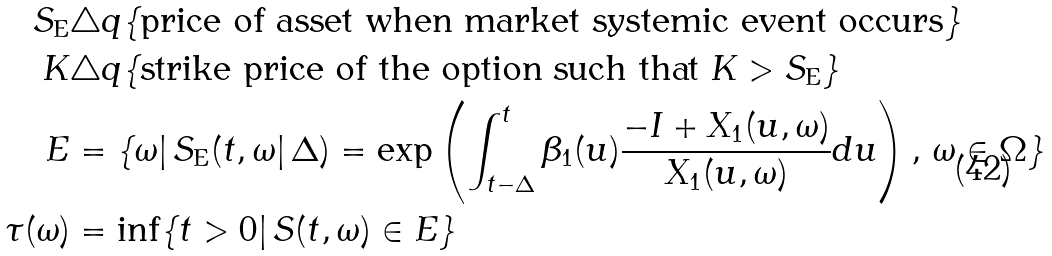Convert formula to latex. <formula><loc_0><loc_0><loc_500><loc_500>S _ { \text {E} } & \triangle q \{ \text {price of asset when market systemic event occurs} \} \\ K & \triangle q \{ \text {strike price of the option such that $K > S_{\text {E}}$} \} \\ E & = \{ \omega | \, S _ { \text {E} } ( t , \omega | \, \Delta ) = \exp \left ( \int ^ { t } _ { t - \Delta } \beta _ { 1 } ( u ) \frac { - I + X _ { 1 } ( u , \omega ) } { X _ { 1 } ( u , \omega ) } d u \right ) , \, \omega \in \Omega \} \\ \tau ( \omega ) & = \inf \{ t > 0 | \, S ( t , \omega ) \in E \}</formula> 